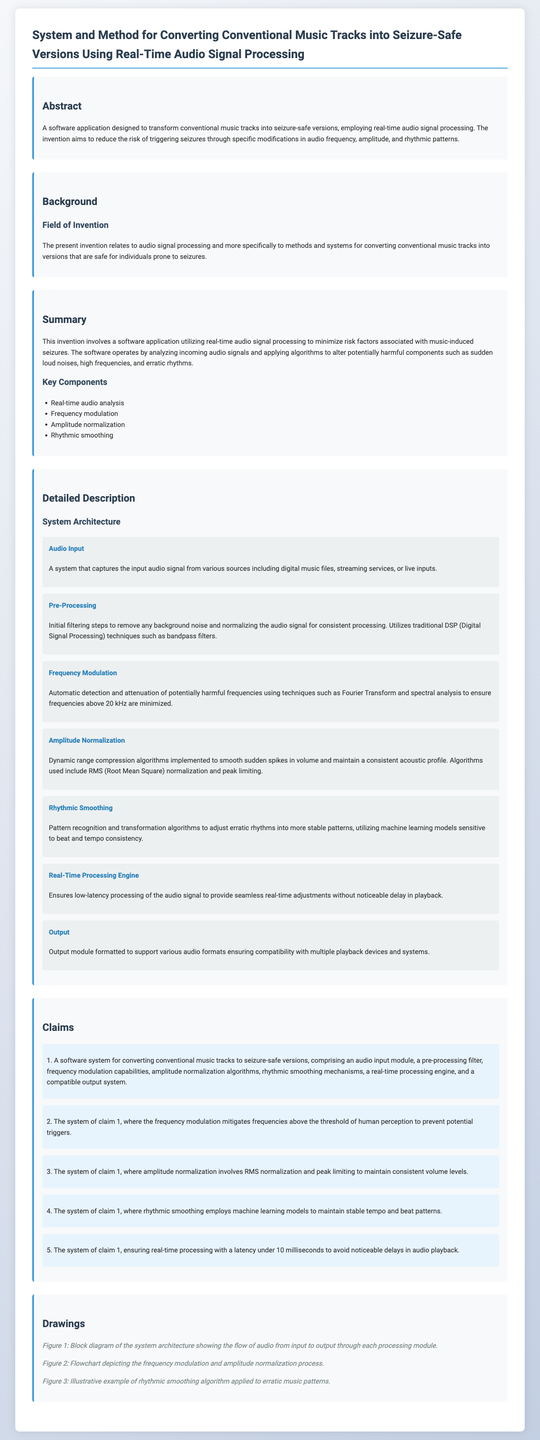What is the title of the patent application? The title is stated at the top of the document under a heading for the main subject, which is "System and Method for Converting Conventional Music Tracks into Seizure-Safe Versions Using Real-Time Audio Signal Processing."
Answer: System and Method for Converting Conventional Music Tracks into Seizure-Safe Versions Using Real-Time Audio Signal Processing What is the purpose of the software application? The purpose is described in the abstract section, which states that it aims to reduce the risk of triggering seizures through specific modifications in audio frequency, amplitude, and rhythmic patterns.
Answer: Reduce the risk of triggering seizures How many key components are listed in the summary? The number of key components is provided in the bullet list format under the summary section of the document.
Answer: Four What processing technique is used for amplitude normalization? The claim clearly specifies the techniques utilized for amplitude normalization in the document, notably in the description section.
Answer: RMS normalization and peak limiting What is the latency requirement for real-time processing? The specific latency requirement is outlined in one of the claims of the document, addressing the efficiency of the processing.
Answer: Under 10 milliseconds Which module captures the input audio signal? The module designated for this function is detailed in the system architecture section, specifying its role in audio signal processing.
Answer: Audio Input What does rhythmic smoothing utilize to maintain stable patterns? The document describes the method utilized in the rhythmic smoothing module to achieve its purpose, which is key for processing.
Answer: Machine learning models How many claims are made in the patent application? The total number of claims is indicated in the claims section, where they are itemized.
Answer: Five 